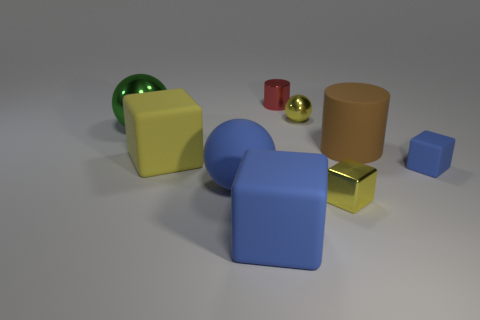Are there more large green metal spheres that are in front of the large yellow block than large green metal things that are in front of the green thing?
Make the answer very short. No. There is a rubber thing that is the same color as the small metal ball; what size is it?
Keep it short and to the point. Large. What number of other objects are there of the same size as the yellow metal cube?
Give a very brief answer. 3. Do the yellow cube that is in front of the big blue matte sphere and the large green sphere have the same material?
Your answer should be very brief. Yes. How many other things are there of the same color as the small ball?
Ensure brevity in your answer.  2. What number of other things are the same shape as the small red metal object?
Your response must be concise. 1. Do the object right of the large brown rubber cylinder and the tiny yellow metal object in front of the large shiny object have the same shape?
Your answer should be compact. Yes. Are there the same number of big brown cylinders in front of the tiny blue cube and large metallic objects left of the large green metallic object?
Keep it short and to the point. Yes. There is a tiny yellow object that is in front of the blue rubber object right of the tiny thing behind the yellow sphere; what is its shape?
Give a very brief answer. Cube. Is the blue ball that is to the left of the big matte cylinder made of the same material as the cylinder that is in front of the tiny red thing?
Offer a terse response. Yes. 